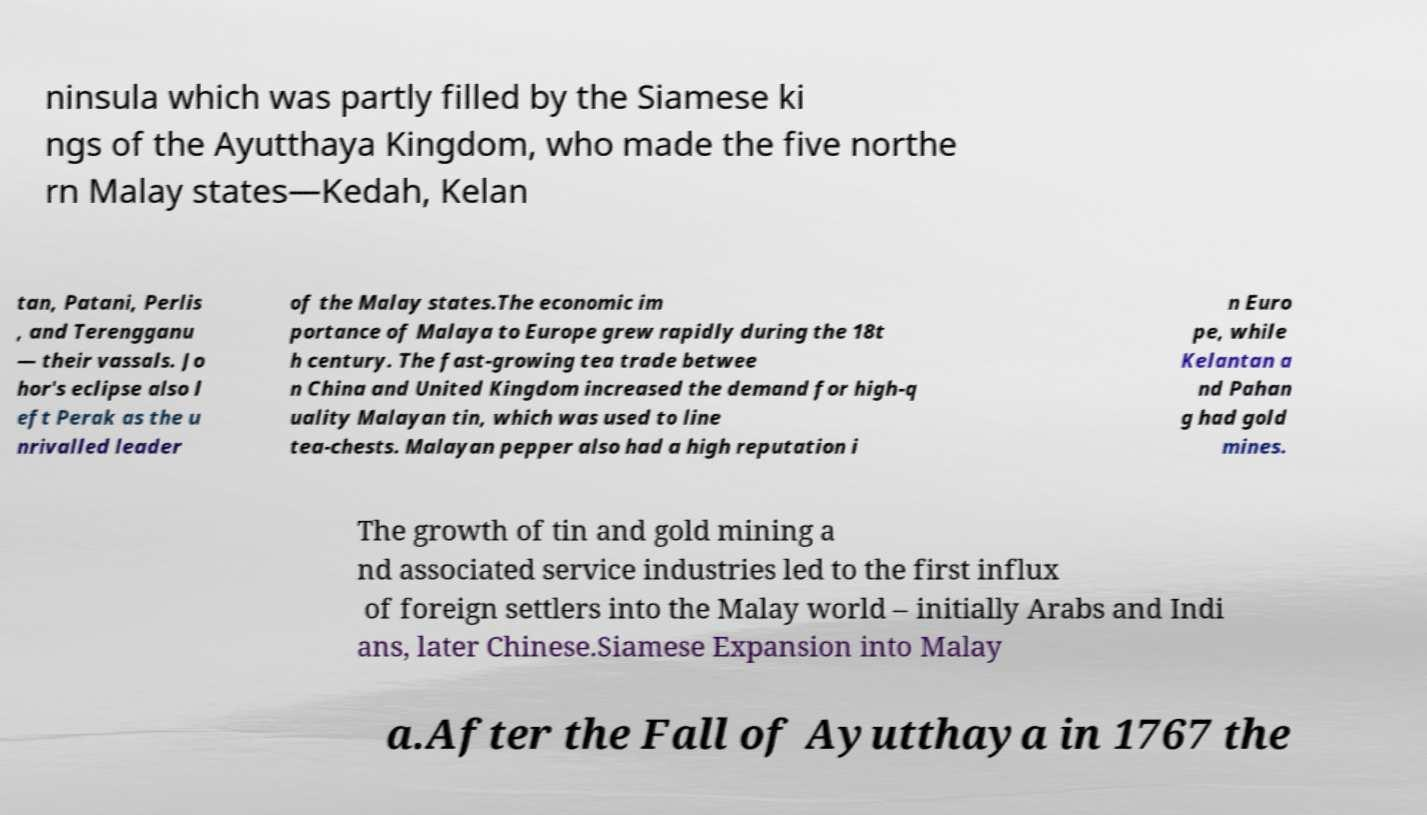There's text embedded in this image that I need extracted. Can you transcribe it verbatim? ninsula which was partly filled by the Siamese ki ngs of the Ayutthaya Kingdom, who made the five northe rn Malay states—Kedah, Kelan tan, Patani, Perlis , and Terengganu — their vassals. Jo hor's eclipse also l eft Perak as the u nrivalled leader of the Malay states.The economic im portance of Malaya to Europe grew rapidly during the 18t h century. The fast-growing tea trade betwee n China and United Kingdom increased the demand for high-q uality Malayan tin, which was used to line tea-chests. Malayan pepper also had a high reputation i n Euro pe, while Kelantan a nd Pahan g had gold mines. The growth of tin and gold mining a nd associated service industries led to the first influx of foreign settlers into the Malay world – initially Arabs and Indi ans, later Chinese.Siamese Expansion into Malay a.After the Fall of Ayutthaya in 1767 the 